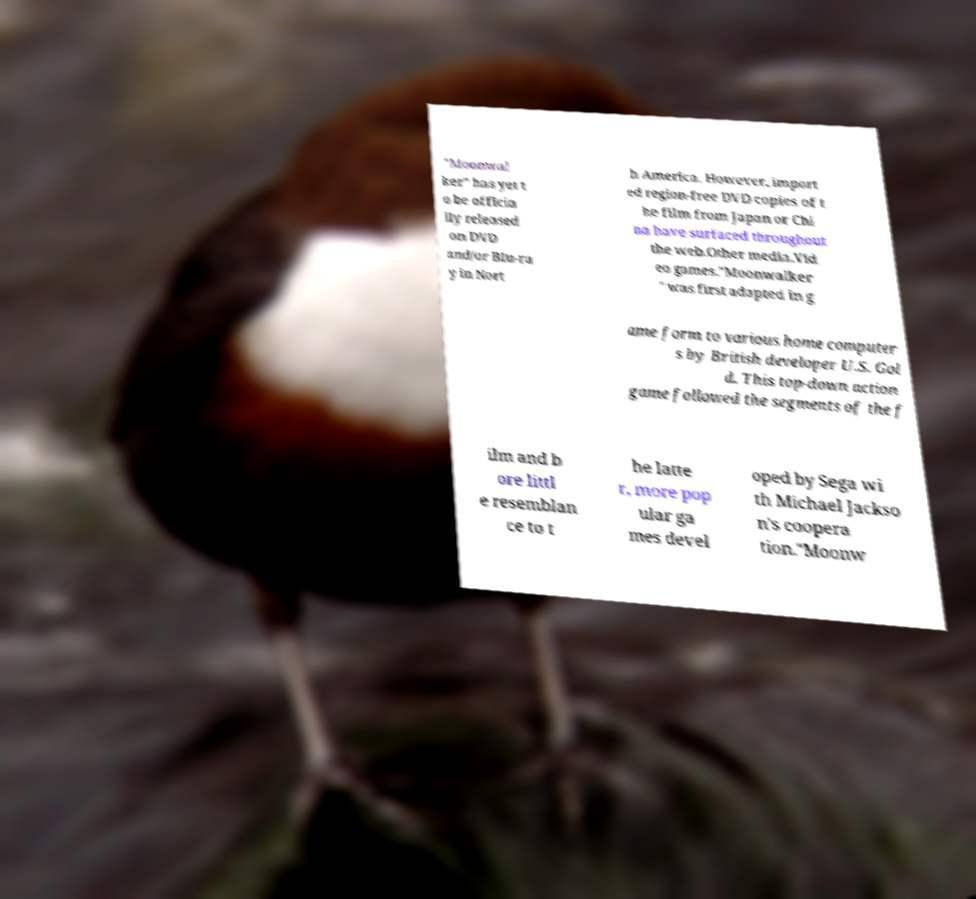Could you extract and type out the text from this image? "Moonwal ker" has yet t o be officia lly released on DVD and/or Blu-ra y in Nort h America. However, import ed region-free DVD copies of t he film from Japan or Chi na have surfaced throughout the web.Other media.Vid eo games."Moonwalker " was first adapted in g ame form to various home computer s by British developer U.S. Gol d. This top-down action game followed the segments of the f ilm and b ore littl e resemblan ce to t he latte r, more pop ular ga mes devel oped by Sega wi th Michael Jackso n's coopera tion."Moonw 